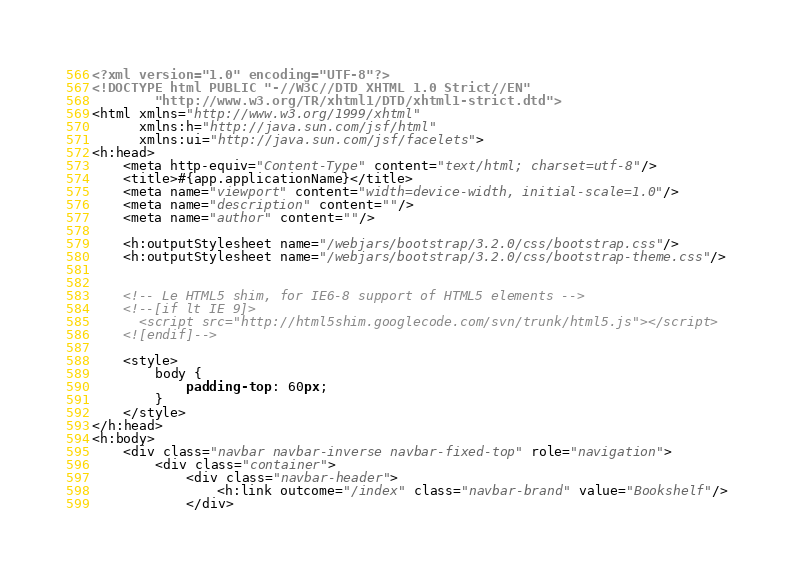Convert code to text. <code><loc_0><loc_0><loc_500><loc_500><_HTML_><?xml version="1.0" encoding="UTF-8"?>
<!DOCTYPE html PUBLIC "-//W3C//DTD XHTML 1.0 Strict//EN"
        "http://www.w3.org/TR/xhtml1/DTD/xhtml1-strict.dtd">
<html xmlns="http://www.w3.org/1999/xhtml"
      xmlns:h="http://java.sun.com/jsf/html"
      xmlns:ui="http://java.sun.com/jsf/facelets">
<h:head>
    <meta http-equiv="Content-Type" content="text/html; charset=utf-8"/>
    <title>#{app.applicationName}</title>
    <meta name="viewport" content="width=device-width, initial-scale=1.0"/>
    <meta name="description" content=""/>
    <meta name="author" content=""/>

    <h:outputStylesheet name="/webjars/bootstrap/3.2.0/css/bootstrap.css"/>
    <h:outputStylesheet name="/webjars/bootstrap/3.2.0/css/bootstrap-theme.css"/>


    <!-- Le HTML5 shim, for IE6-8 support of HTML5 elements -->
    <!--[if lt IE 9]>
      <script src="http://html5shim.googlecode.com/svn/trunk/html5.js"></script>
    <![endif]-->

    <style>
        body {
            padding-top: 60px;
        }
    </style>
</h:head>
<h:body>
    <div class="navbar navbar-inverse navbar-fixed-top" role="navigation">
        <div class="container">
            <div class="navbar-header">
                <h:link outcome="/index" class="navbar-brand" value="Bookshelf"/>
            </div></code> 